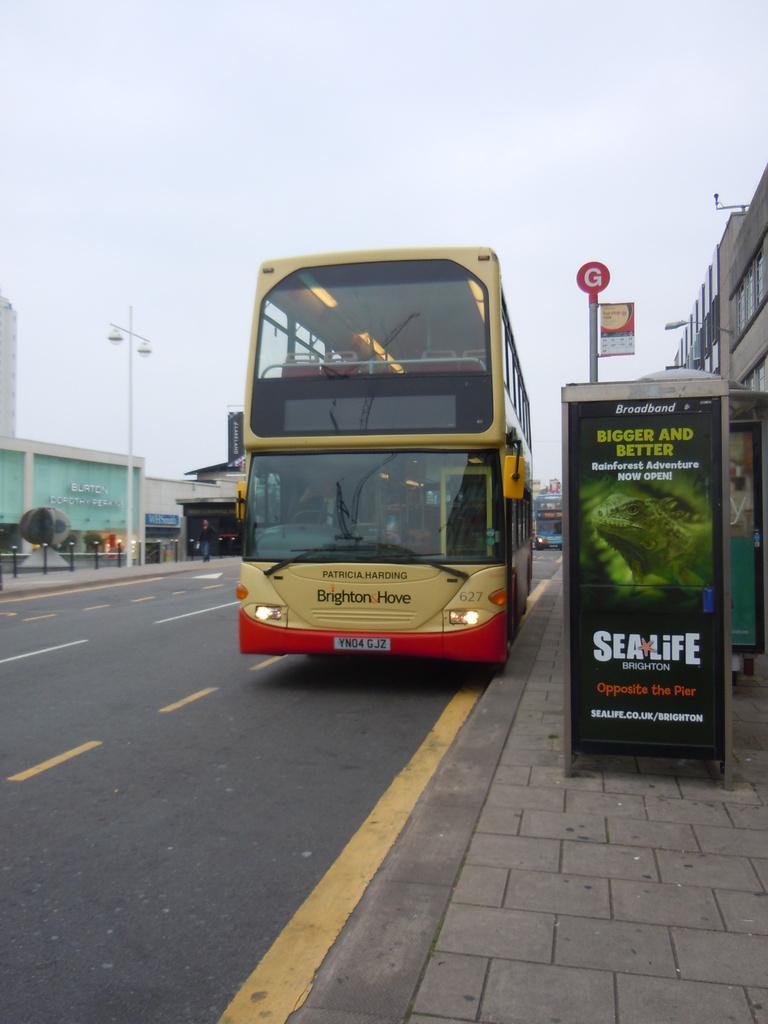Can you describe this image briefly? As we can see in the image there is bus, banner and at the top there is sky. There are buildings, street lamps and lights. 